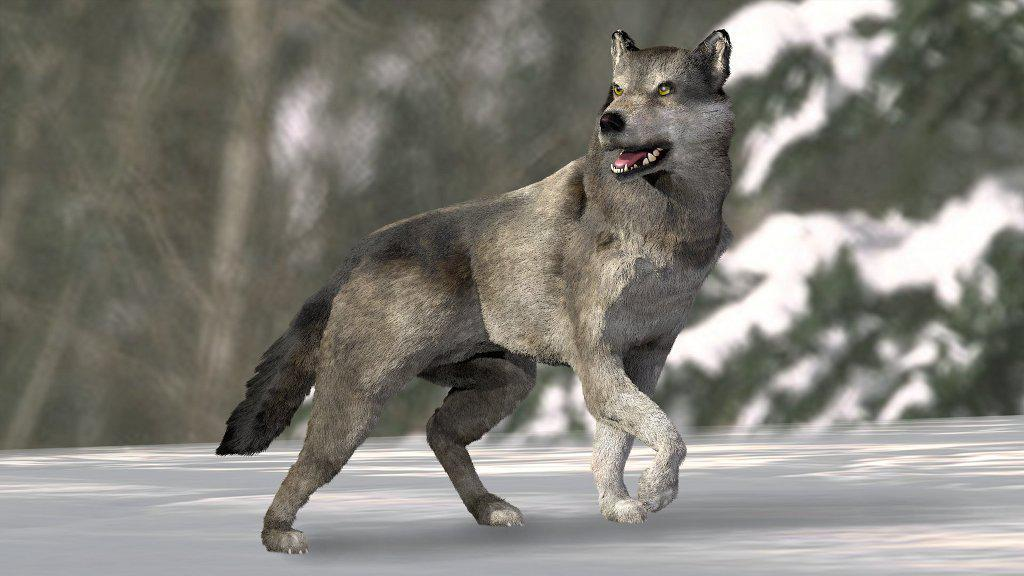What is the main subject of the image? There is a fox in the center of the image. Can you describe the background of the image? The background of the image is not clear. What is the fox's interest in the cover of the book in the image? There is no book or cover present in the image; it only features a fox. 